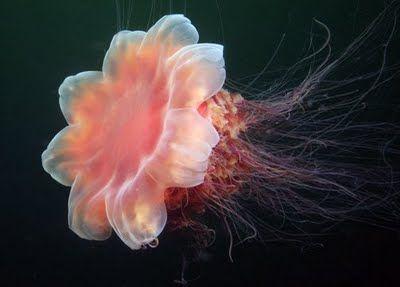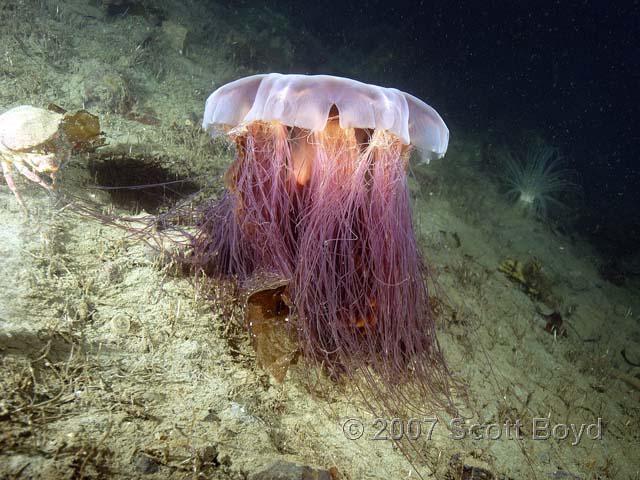The first image is the image on the left, the second image is the image on the right. Given the left and right images, does the statement "An image shows a mushroom-shaped purplish jellyfish with tentacles reaching in all directions and enveloping at least one other creature." hold true? Answer yes or no. No. The first image is the image on the left, the second image is the image on the right. Analyze the images presented: Is the assertion "in at least one image there is at least two jellyfish with at least one that is both red, black and fire colored." valid? Answer yes or no. No. 